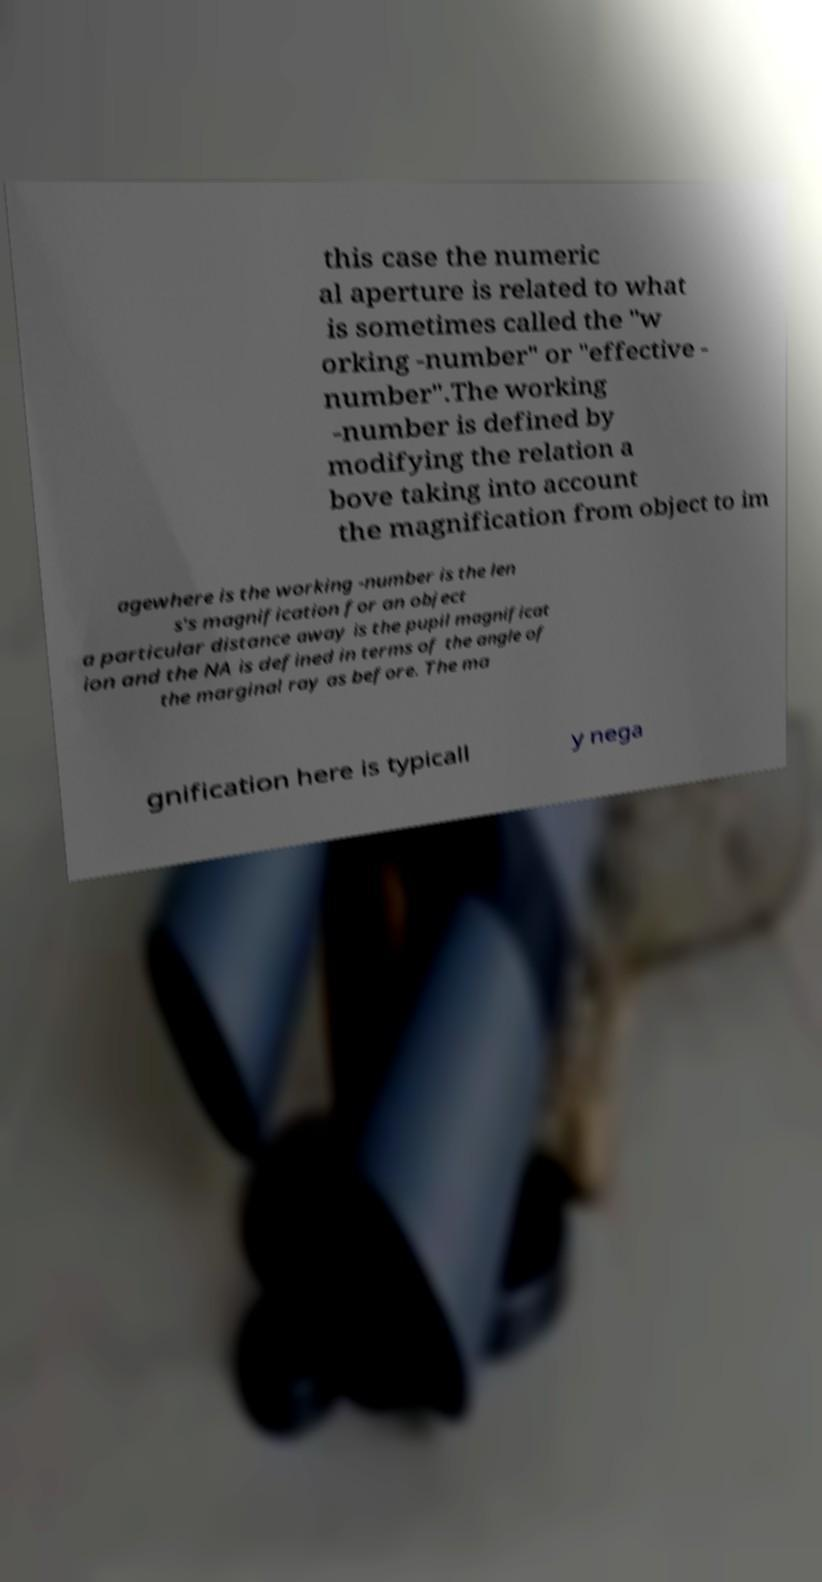Could you assist in decoding the text presented in this image and type it out clearly? this case the numeric al aperture is related to what is sometimes called the "w orking -number" or "effective - number".The working -number is defined by modifying the relation a bove taking into account the magnification from object to im agewhere is the working -number is the len s's magnification for an object a particular distance away is the pupil magnificat ion and the NA is defined in terms of the angle of the marginal ray as before. The ma gnification here is typicall y nega 